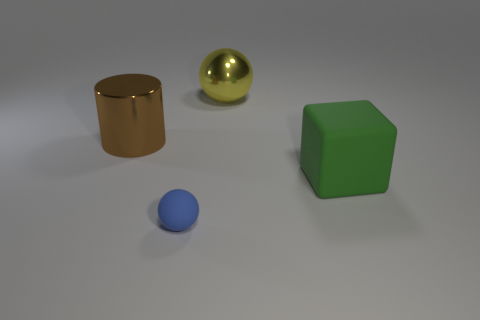Is the big brown thing behind the large matte block made of the same material as the thing to the right of the big metallic sphere? no 